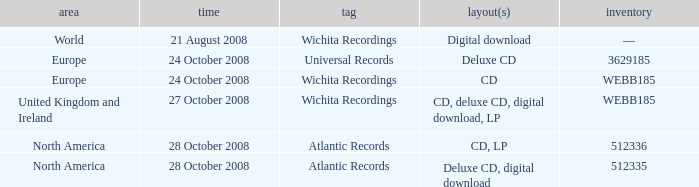What are the formats associated with the Atlantic Records label, catalog number 512336? CD, LP. Write the full table. {'header': ['area', 'time', 'tag', 'layout(s)', 'inventory'], 'rows': [['World', '21 August 2008', 'Wichita Recordings', 'Digital download', '—'], ['Europe', '24 October 2008', 'Universal Records', 'Deluxe CD', '3629185'], ['Europe', '24 October 2008', 'Wichita Recordings', 'CD', 'WEBB185'], ['United Kingdom and Ireland', '27 October 2008', 'Wichita Recordings', 'CD, deluxe CD, digital download, LP', 'WEBB185'], ['North America', '28 October 2008', 'Atlantic Records', 'CD, LP', '512336'], ['North America', '28 October 2008', 'Atlantic Records', 'Deluxe CD, digital download', '512335']]} 